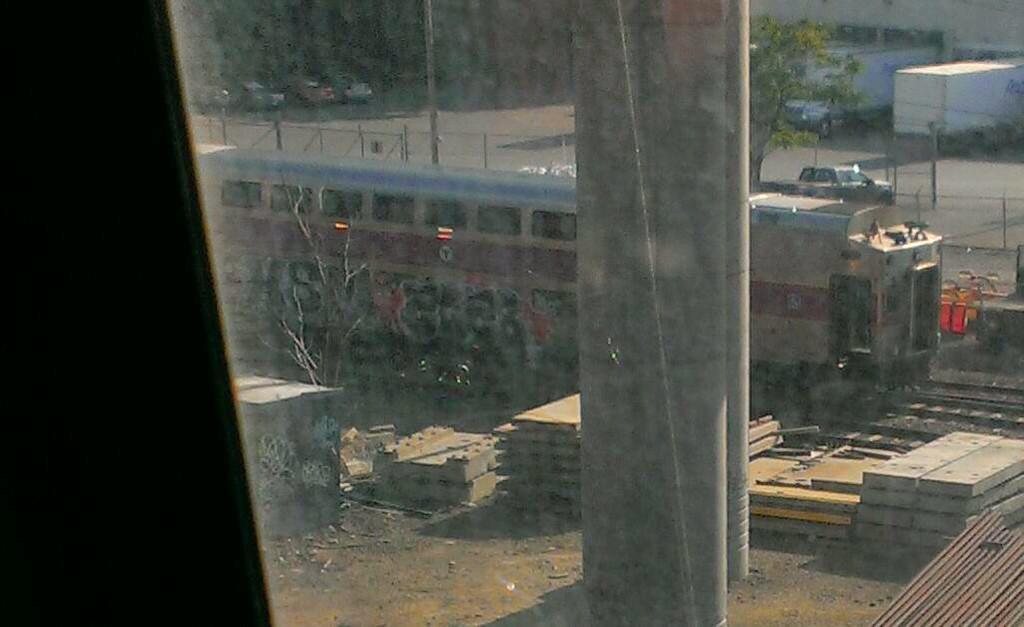Describe this image in one or two sentences. In this image we can see a train, there are some poles, pillars, trees, vehicles, fence and other objects on the ground. 